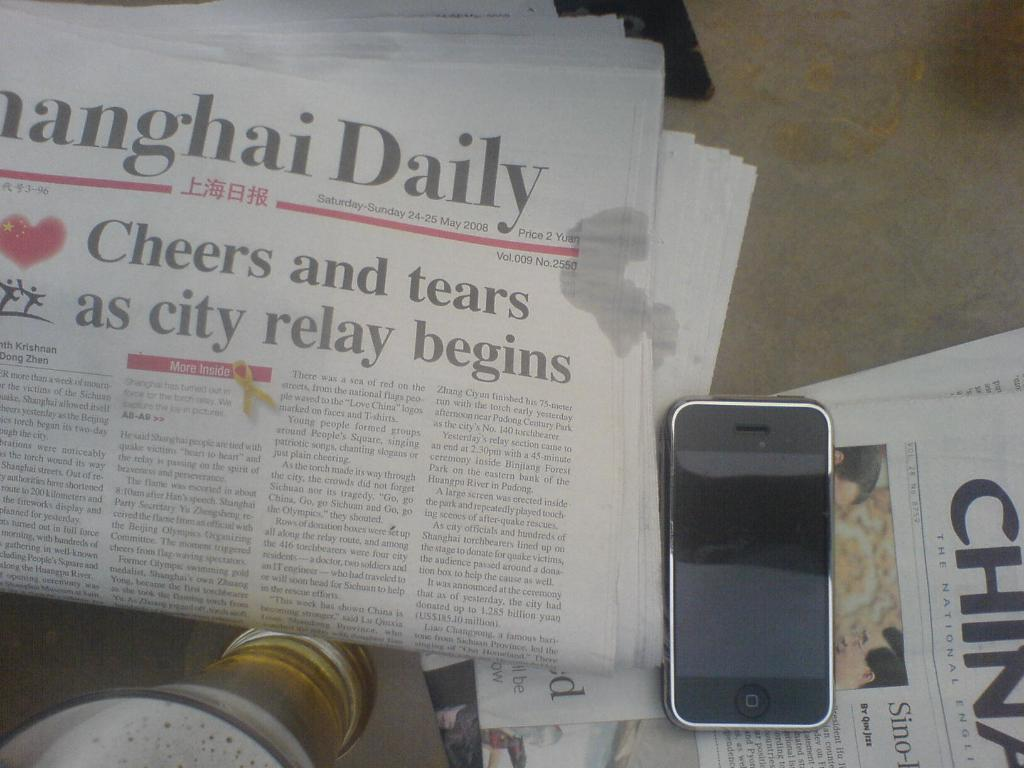Provide a one-sentence caption for the provided image. A newspaper that was published by the Shanghai Daily. 